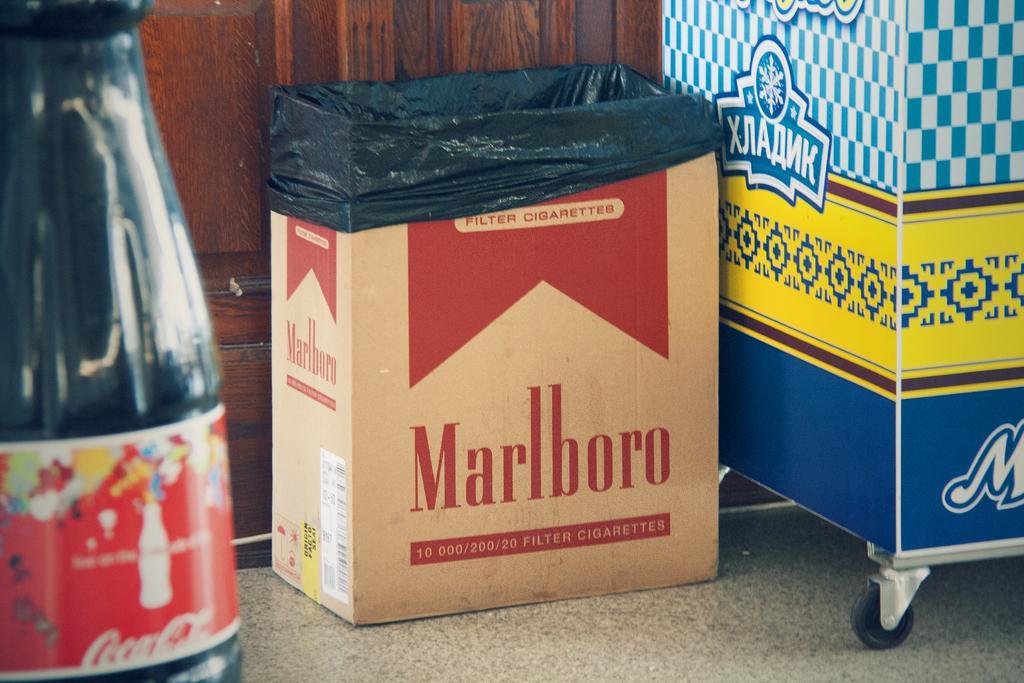Please provide a concise description of this image. In the image we can see there is a cardboard box kept on the floor and there is a juice bottle kept on the floor. There is a trolley vehicle on the floor and it's written ¨Marlboro¨ on the cardboard box. 